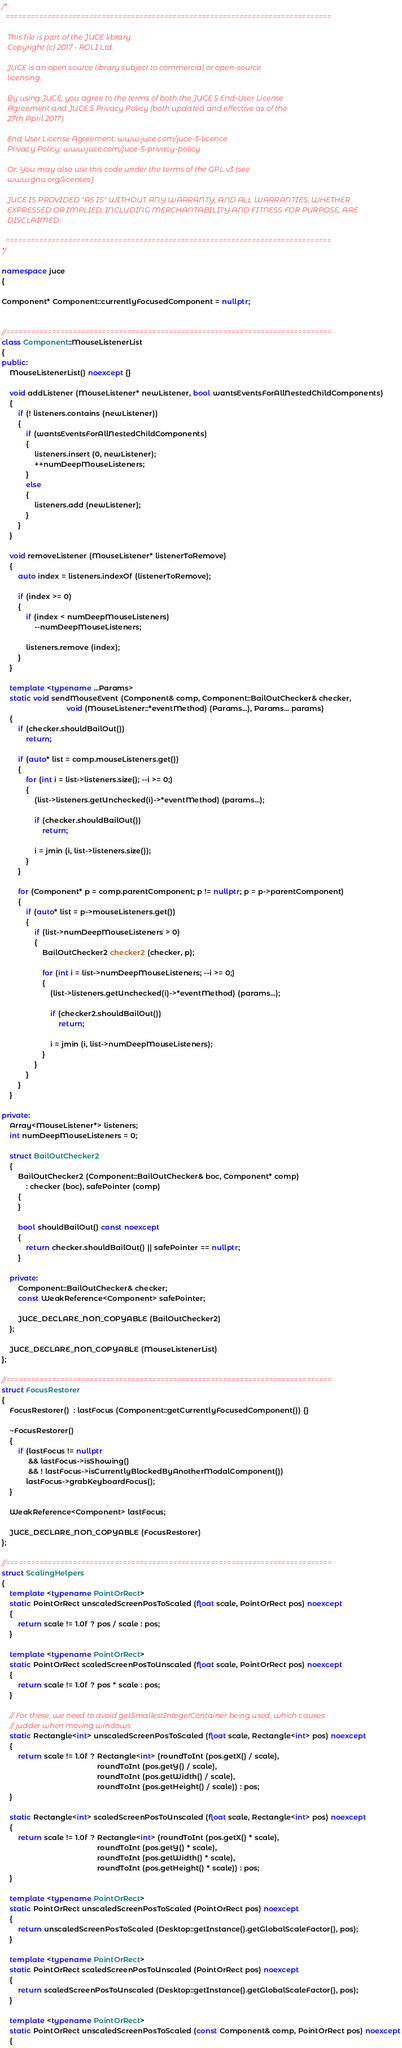<code> <loc_0><loc_0><loc_500><loc_500><_C++_>/*
  ==============================================================================

   This file is part of the JUCE library.
   Copyright (c) 2017 - ROLI Ltd.

   JUCE is an open source library subject to commercial or open-source
   licensing.

   By using JUCE, you agree to the terms of both the JUCE 5 End-User License
   Agreement and JUCE 5 Privacy Policy (both updated and effective as of the
   27th April 2017).

   End User License Agreement: www.juce.com/juce-5-licence
   Privacy Policy: www.juce.com/juce-5-privacy-policy

   Or: You may also use this code under the terms of the GPL v3 (see
   www.gnu.org/licenses).

   JUCE IS PROVIDED "AS IS" WITHOUT ANY WARRANTY, AND ALL WARRANTIES, WHETHER
   EXPRESSED OR IMPLIED, INCLUDING MERCHANTABILITY AND FITNESS FOR PURPOSE, ARE
   DISCLAIMED.

  ==============================================================================
*/

namespace juce
{

Component* Component::currentlyFocusedComponent = nullptr;


//==============================================================================
class Component::MouseListenerList
{
public:
    MouseListenerList() noexcept {}

    void addListener (MouseListener* newListener, bool wantsEventsForAllNestedChildComponents)
    {
        if (! listeners.contains (newListener))
        {
            if (wantsEventsForAllNestedChildComponents)
            {
                listeners.insert (0, newListener);
                ++numDeepMouseListeners;
            }
            else
            {
                listeners.add (newListener);
            }
        }
    }

    void removeListener (MouseListener* listenerToRemove)
    {
        auto index = listeners.indexOf (listenerToRemove);

        if (index >= 0)
        {
            if (index < numDeepMouseListeners)
                --numDeepMouseListeners;

            listeners.remove (index);
        }
    }

    template <typename ...Params>
    static void sendMouseEvent (Component& comp, Component::BailOutChecker& checker,
                                void (MouseListener::*eventMethod) (Params...), Params... params)
    {
        if (checker.shouldBailOut())
            return;

        if (auto* list = comp.mouseListeners.get())
        {
            for (int i = list->listeners.size(); --i >= 0;)
            {
                (list->listeners.getUnchecked(i)->*eventMethod) (params...);

                if (checker.shouldBailOut())
                    return;

                i = jmin (i, list->listeners.size());
            }
        }

        for (Component* p = comp.parentComponent; p != nullptr; p = p->parentComponent)
        {
            if (auto* list = p->mouseListeners.get())
            {
                if (list->numDeepMouseListeners > 0)
                {
                    BailOutChecker2 checker2 (checker, p);

                    for (int i = list->numDeepMouseListeners; --i >= 0;)
                    {
                        (list->listeners.getUnchecked(i)->*eventMethod) (params...);

                        if (checker2.shouldBailOut())
                            return;

                        i = jmin (i, list->numDeepMouseListeners);
                    }
                }
            }
        }
    }

private:
    Array<MouseListener*> listeners;
    int numDeepMouseListeners = 0;

    struct BailOutChecker2
    {
        BailOutChecker2 (Component::BailOutChecker& boc, Component* comp)
            : checker (boc), safePointer (comp)
        {
        }

        bool shouldBailOut() const noexcept
        {
            return checker.shouldBailOut() || safePointer == nullptr;
        }

    private:
        Component::BailOutChecker& checker;
        const WeakReference<Component> safePointer;

        JUCE_DECLARE_NON_COPYABLE (BailOutChecker2)
    };

    JUCE_DECLARE_NON_COPYABLE (MouseListenerList)
};

//==============================================================================
struct FocusRestorer
{
    FocusRestorer()  : lastFocus (Component::getCurrentlyFocusedComponent()) {}

    ~FocusRestorer()
    {
        if (lastFocus != nullptr
             && lastFocus->isShowing()
             && ! lastFocus->isCurrentlyBlockedByAnotherModalComponent())
            lastFocus->grabKeyboardFocus();
    }

    WeakReference<Component> lastFocus;

    JUCE_DECLARE_NON_COPYABLE (FocusRestorer)
};

//==============================================================================
struct ScalingHelpers
{
    template <typename PointOrRect>
    static PointOrRect unscaledScreenPosToScaled (float scale, PointOrRect pos) noexcept
    {
        return scale != 1.0f ? pos / scale : pos;
    }

    template <typename PointOrRect>
    static PointOrRect scaledScreenPosToUnscaled (float scale, PointOrRect pos) noexcept
    {
        return scale != 1.0f ? pos * scale : pos;
    }

    // For these, we need to avoid getSmallestIntegerContainer being used, which causes
    // judder when moving windows
    static Rectangle<int> unscaledScreenPosToScaled (float scale, Rectangle<int> pos) noexcept
    {
        return scale != 1.0f ? Rectangle<int> (roundToInt (pos.getX() / scale),
                                               roundToInt (pos.getY() / scale),
                                               roundToInt (pos.getWidth() / scale),
                                               roundToInt (pos.getHeight() / scale)) : pos;
    }

    static Rectangle<int> scaledScreenPosToUnscaled (float scale, Rectangle<int> pos) noexcept
    {
        return scale != 1.0f ? Rectangle<int> (roundToInt (pos.getX() * scale),
                                               roundToInt (pos.getY() * scale),
                                               roundToInt (pos.getWidth() * scale),
                                               roundToInt (pos.getHeight() * scale)) : pos;
    }

    template <typename PointOrRect>
    static PointOrRect unscaledScreenPosToScaled (PointOrRect pos) noexcept
    {
        return unscaledScreenPosToScaled (Desktop::getInstance().getGlobalScaleFactor(), pos);
    }

    template <typename PointOrRect>
    static PointOrRect scaledScreenPosToUnscaled (PointOrRect pos) noexcept
    {
        return scaledScreenPosToUnscaled (Desktop::getInstance().getGlobalScaleFactor(), pos);
    }

    template <typename PointOrRect>
    static PointOrRect unscaledScreenPosToScaled (const Component& comp, PointOrRect pos) noexcept
    {</code> 